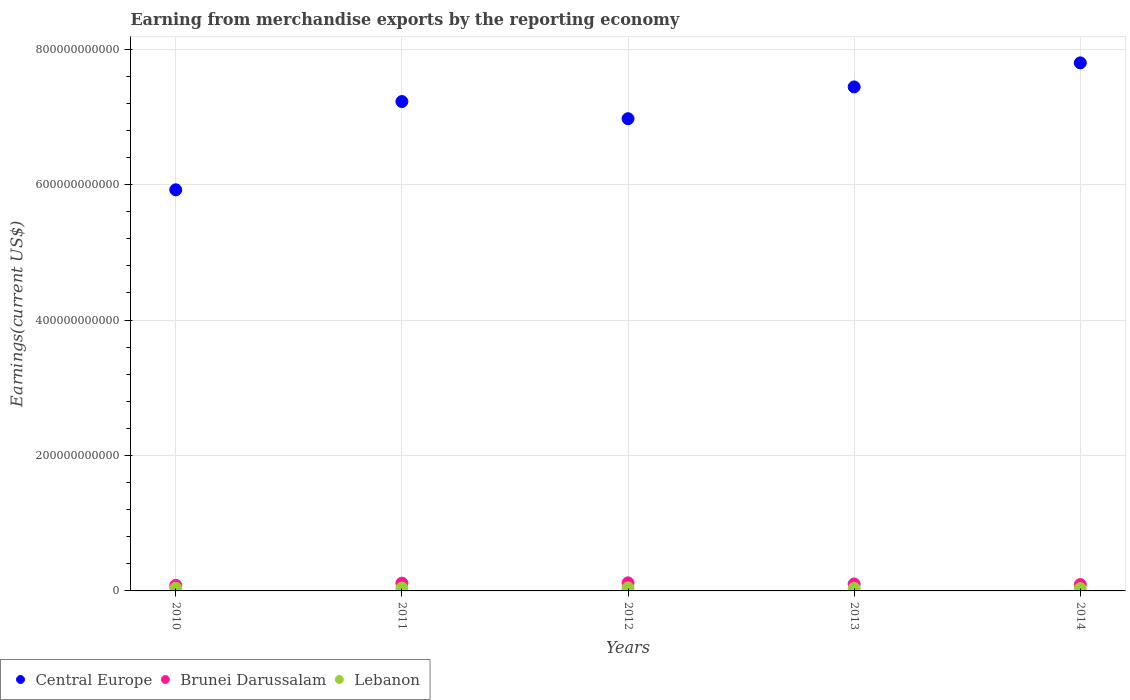What is the amount earned from merchandise exports in Brunei Darussalam in 2011?
Provide a succinct answer. 1.15e+1. Across all years, what is the maximum amount earned from merchandise exports in Central Europe?
Offer a terse response. 7.80e+11. Across all years, what is the minimum amount earned from merchandise exports in Central Europe?
Keep it short and to the point. 5.92e+11. What is the total amount earned from merchandise exports in Central Europe in the graph?
Offer a terse response. 3.54e+12. What is the difference between the amount earned from merchandise exports in Brunei Darussalam in 2013 and that in 2014?
Offer a very short reply. 9.11e+08. What is the difference between the amount earned from merchandise exports in Lebanon in 2011 and the amount earned from merchandise exports in Brunei Darussalam in 2014?
Your answer should be compact. -5.16e+09. What is the average amount earned from merchandise exports in Lebanon per year?
Your answer should be compact. 3.93e+09. In the year 2011, what is the difference between the amount earned from merchandise exports in Central Europe and amount earned from merchandise exports in Brunei Darussalam?
Keep it short and to the point. 7.11e+11. What is the ratio of the amount earned from merchandise exports in Lebanon in 2010 to that in 2012?
Your response must be concise. 0.86. Is the amount earned from merchandise exports in Lebanon in 2013 less than that in 2014?
Give a very brief answer. No. Is the difference between the amount earned from merchandise exports in Central Europe in 2010 and 2013 greater than the difference between the amount earned from merchandise exports in Brunei Darussalam in 2010 and 2013?
Offer a terse response. No. What is the difference between the highest and the second highest amount earned from merchandise exports in Lebanon?
Provide a succinct answer. 2.82e+08. What is the difference between the highest and the lowest amount earned from merchandise exports in Brunei Darussalam?
Your answer should be compact. 3.66e+09. How many dotlines are there?
Provide a short and direct response. 3. How many years are there in the graph?
Your answer should be compact. 5. What is the difference between two consecutive major ticks on the Y-axis?
Provide a short and direct response. 2.00e+11. Does the graph contain any zero values?
Your answer should be very brief. No. Where does the legend appear in the graph?
Make the answer very short. Bottom left. What is the title of the graph?
Ensure brevity in your answer.  Earning from merchandise exports by the reporting economy. What is the label or title of the X-axis?
Ensure brevity in your answer.  Years. What is the label or title of the Y-axis?
Your answer should be compact. Earnings(current US$). What is the Earnings(current US$) in Central Europe in 2010?
Provide a short and direct response. 5.92e+11. What is the Earnings(current US$) of Brunei Darussalam in 2010?
Provide a short and direct response. 8.26e+09. What is the Earnings(current US$) of Lebanon in 2010?
Your answer should be very brief. 3.86e+09. What is the Earnings(current US$) in Central Europe in 2011?
Your answer should be compact. 7.23e+11. What is the Earnings(current US$) of Brunei Darussalam in 2011?
Give a very brief answer. 1.15e+1. What is the Earnings(current US$) of Lebanon in 2011?
Your answer should be compact. 4.20e+09. What is the Earnings(current US$) of Central Europe in 2012?
Your answer should be very brief. 6.97e+11. What is the Earnings(current US$) of Brunei Darussalam in 2012?
Offer a terse response. 1.19e+1. What is the Earnings(current US$) of Lebanon in 2012?
Your answer should be compact. 4.48e+09. What is the Earnings(current US$) of Central Europe in 2013?
Your answer should be compact. 7.44e+11. What is the Earnings(current US$) in Brunei Darussalam in 2013?
Make the answer very short. 1.03e+1. What is the Earnings(current US$) of Lebanon in 2013?
Your response must be concise. 3.70e+09. What is the Earnings(current US$) in Central Europe in 2014?
Your answer should be compact. 7.80e+11. What is the Earnings(current US$) of Brunei Darussalam in 2014?
Offer a very short reply. 9.37e+09. What is the Earnings(current US$) of Lebanon in 2014?
Ensure brevity in your answer.  3.41e+09. Across all years, what is the maximum Earnings(current US$) in Central Europe?
Your answer should be compact. 7.80e+11. Across all years, what is the maximum Earnings(current US$) of Brunei Darussalam?
Your response must be concise. 1.19e+1. Across all years, what is the maximum Earnings(current US$) of Lebanon?
Provide a succinct answer. 4.48e+09. Across all years, what is the minimum Earnings(current US$) in Central Europe?
Your answer should be compact. 5.92e+11. Across all years, what is the minimum Earnings(current US$) of Brunei Darussalam?
Give a very brief answer. 8.26e+09. Across all years, what is the minimum Earnings(current US$) in Lebanon?
Your response must be concise. 3.41e+09. What is the total Earnings(current US$) of Central Europe in the graph?
Your response must be concise. 3.54e+12. What is the total Earnings(current US$) of Brunei Darussalam in the graph?
Provide a succinct answer. 5.13e+1. What is the total Earnings(current US$) of Lebanon in the graph?
Offer a very short reply. 1.96e+1. What is the difference between the Earnings(current US$) of Central Europe in 2010 and that in 2011?
Keep it short and to the point. -1.30e+11. What is the difference between the Earnings(current US$) of Brunei Darussalam in 2010 and that in 2011?
Ensure brevity in your answer.  -3.23e+09. What is the difference between the Earnings(current US$) in Lebanon in 2010 and that in 2011?
Ensure brevity in your answer.  -3.42e+08. What is the difference between the Earnings(current US$) in Central Europe in 2010 and that in 2012?
Your answer should be very brief. -1.05e+11. What is the difference between the Earnings(current US$) of Brunei Darussalam in 2010 and that in 2012?
Keep it short and to the point. -3.66e+09. What is the difference between the Earnings(current US$) of Lebanon in 2010 and that in 2012?
Ensure brevity in your answer.  -6.24e+08. What is the difference between the Earnings(current US$) of Central Europe in 2010 and that in 2013?
Offer a terse response. -1.52e+11. What is the difference between the Earnings(current US$) of Brunei Darussalam in 2010 and that in 2013?
Your response must be concise. -2.02e+09. What is the difference between the Earnings(current US$) of Lebanon in 2010 and that in 2013?
Give a very brief answer. 1.64e+08. What is the difference between the Earnings(current US$) in Central Europe in 2010 and that in 2014?
Your answer should be compact. -1.87e+11. What is the difference between the Earnings(current US$) of Brunei Darussalam in 2010 and that in 2014?
Offer a very short reply. -1.11e+09. What is the difference between the Earnings(current US$) in Lebanon in 2010 and that in 2014?
Provide a succinct answer. 4.49e+08. What is the difference between the Earnings(current US$) of Central Europe in 2011 and that in 2012?
Offer a terse response. 2.54e+1. What is the difference between the Earnings(current US$) in Brunei Darussalam in 2011 and that in 2012?
Keep it short and to the point. -4.32e+08. What is the difference between the Earnings(current US$) in Lebanon in 2011 and that in 2012?
Offer a terse response. -2.82e+08. What is the difference between the Earnings(current US$) of Central Europe in 2011 and that in 2013?
Make the answer very short. -2.16e+1. What is the difference between the Earnings(current US$) in Brunei Darussalam in 2011 and that in 2013?
Offer a very short reply. 1.21e+09. What is the difference between the Earnings(current US$) in Lebanon in 2011 and that in 2013?
Provide a short and direct response. 5.06e+08. What is the difference between the Earnings(current US$) in Central Europe in 2011 and that in 2014?
Give a very brief answer. -5.71e+1. What is the difference between the Earnings(current US$) of Brunei Darussalam in 2011 and that in 2014?
Your response must be concise. 2.12e+09. What is the difference between the Earnings(current US$) in Lebanon in 2011 and that in 2014?
Provide a short and direct response. 7.91e+08. What is the difference between the Earnings(current US$) of Central Europe in 2012 and that in 2013?
Offer a very short reply. -4.69e+1. What is the difference between the Earnings(current US$) in Brunei Darussalam in 2012 and that in 2013?
Ensure brevity in your answer.  1.64e+09. What is the difference between the Earnings(current US$) in Lebanon in 2012 and that in 2013?
Your response must be concise. 7.88e+08. What is the difference between the Earnings(current US$) in Central Europe in 2012 and that in 2014?
Give a very brief answer. -8.25e+1. What is the difference between the Earnings(current US$) of Brunei Darussalam in 2012 and that in 2014?
Your response must be concise. 2.55e+09. What is the difference between the Earnings(current US$) in Lebanon in 2012 and that in 2014?
Your answer should be very brief. 1.07e+09. What is the difference between the Earnings(current US$) of Central Europe in 2013 and that in 2014?
Ensure brevity in your answer.  -3.55e+1. What is the difference between the Earnings(current US$) of Brunei Darussalam in 2013 and that in 2014?
Give a very brief answer. 9.11e+08. What is the difference between the Earnings(current US$) in Lebanon in 2013 and that in 2014?
Your answer should be very brief. 2.85e+08. What is the difference between the Earnings(current US$) of Central Europe in 2010 and the Earnings(current US$) of Brunei Darussalam in 2011?
Ensure brevity in your answer.  5.81e+11. What is the difference between the Earnings(current US$) of Central Europe in 2010 and the Earnings(current US$) of Lebanon in 2011?
Provide a short and direct response. 5.88e+11. What is the difference between the Earnings(current US$) in Brunei Darussalam in 2010 and the Earnings(current US$) in Lebanon in 2011?
Your response must be concise. 4.05e+09. What is the difference between the Earnings(current US$) in Central Europe in 2010 and the Earnings(current US$) in Brunei Darussalam in 2012?
Offer a very short reply. 5.80e+11. What is the difference between the Earnings(current US$) in Central Europe in 2010 and the Earnings(current US$) in Lebanon in 2012?
Make the answer very short. 5.88e+11. What is the difference between the Earnings(current US$) of Brunei Darussalam in 2010 and the Earnings(current US$) of Lebanon in 2012?
Offer a very short reply. 3.77e+09. What is the difference between the Earnings(current US$) of Central Europe in 2010 and the Earnings(current US$) of Brunei Darussalam in 2013?
Your answer should be compact. 5.82e+11. What is the difference between the Earnings(current US$) of Central Europe in 2010 and the Earnings(current US$) of Lebanon in 2013?
Your answer should be very brief. 5.89e+11. What is the difference between the Earnings(current US$) in Brunei Darussalam in 2010 and the Earnings(current US$) in Lebanon in 2013?
Provide a short and direct response. 4.56e+09. What is the difference between the Earnings(current US$) of Central Europe in 2010 and the Earnings(current US$) of Brunei Darussalam in 2014?
Provide a short and direct response. 5.83e+11. What is the difference between the Earnings(current US$) in Central Europe in 2010 and the Earnings(current US$) in Lebanon in 2014?
Provide a short and direct response. 5.89e+11. What is the difference between the Earnings(current US$) in Brunei Darussalam in 2010 and the Earnings(current US$) in Lebanon in 2014?
Provide a succinct answer. 4.85e+09. What is the difference between the Earnings(current US$) of Central Europe in 2011 and the Earnings(current US$) of Brunei Darussalam in 2012?
Ensure brevity in your answer.  7.11e+11. What is the difference between the Earnings(current US$) in Central Europe in 2011 and the Earnings(current US$) in Lebanon in 2012?
Ensure brevity in your answer.  7.18e+11. What is the difference between the Earnings(current US$) in Brunei Darussalam in 2011 and the Earnings(current US$) in Lebanon in 2012?
Provide a succinct answer. 7.00e+09. What is the difference between the Earnings(current US$) in Central Europe in 2011 and the Earnings(current US$) in Brunei Darussalam in 2013?
Keep it short and to the point. 7.12e+11. What is the difference between the Earnings(current US$) of Central Europe in 2011 and the Earnings(current US$) of Lebanon in 2013?
Your answer should be very brief. 7.19e+11. What is the difference between the Earnings(current US$) in Brunei Darussalam in 2011 and the Earnings(current US$) in Lebanon in 2013?
Ensure brevity in your answer.  7.79e+09. What is the difference between the Earnings(current US$) of Central Europe in 2011 and the Earnings(current US$) of Brunei Darussalam in 2014?
Offer a terse response. 7.13e+11. What is the difference between the Earnings(current US$) in Central Europe in 2011 and the Earnings(current US$) in Lebanon in 2014?
Your answer should be compact. 7.19e+11. What is the difference between the Earnings(current US$) in Brunei Darussalam in 2011 and the Earnings(current US$) in Lebanon in 2014?
Provide a succinct answer. 8.07e+09. What is the difference between the Earnings(current US$) of Central Europe in 2012 and the Earnings(current US$) of Brunei Darussalam in 2013?
Make the answer very short. 6.87e+11. What is the difference between the Earnings(current US$) in Central Europe in 2012 and the Earnings(current US$) in Lebanon in 2013?
Offer a terse response. 6.94e+11. What is the difference between the Earnings(current US$) in Brunei Darussalam in 2012 and the Earnings(current US$) in Lebanon in 2013?
Give a very brief answer. 8.22e+09. What is the difference between the Earnings(current US$) of Central Europe in 2012 and the Earnings(current US$) of Brunei Darussalam in 2014?
Give a very brief answer. 6.88e+11. What is the difference between the Earnings(current US$) in Central Europe in 2012 and the Earnings(current US$) in Lebanon in 2014?
Your answer should be very brief. 6.94e+11. What is the difference between the Earnings(current US$) of Brunei Darussalam in 2012 and the Earnings(current US$) of Lebanon in 2014?
Keep it short and to the point. 8.51e+09. What is the difference between the Earnings(current US$) of Central Europe in 2013 and the Earnings(current US$) of Brunei Darussalam in 2014?
Provide a short and direct response. 7.35e+11. What is the difference between the Earnings(current US$) of Central Europe in 2013 and the Earnings(current US$) of Lebanon in 2014?
Provide a short and direct response. 7.41e+11. What is the difference between the Earnings(current US$) of Brunei Darussalam in 2013 and the Earnings(current US$) of Lebanon in 2014?
Provide a succinct answer. 6.87e+09. What is the average Earnings(current US$) in Central Europe per year?
Your response must be concise. 7.07e+11. What is the average Earnings(current US$) of Brunei Darussalam per year?
Keep it short and to the point. 1.03e+1. What is the average Earnings(current US$) in Lebanon per year?
Provide a succinct answer. 3.93e+09. In the year 2010, what is the difference between the Earnings(current US$) in Central Europe and Earnings(current US$) in Brunei Darussalam?
Keep it short and to the point. 5.84e+11. In the year 2010, what is the difference between the Earnings(current US$) of Central Europe and Earnings(current US$) of Lebanon?
Your response must be concise. 5.89e+11. In the year 2010, what is the difference between the Earnings(current US$) of Brunei Darussalam and Earnings(current US$) of Lebanon?
Your answer should be compact. 4.40e+09. In the year 2011, what is the difference between the Earnings(current US$) in Central Europe and Earnings(current US$) in Brunei Darussalam?
Keep it short and to the point. 7.11e+11. In the year 2011, what is the difference between the Earnings(current US$) in Central Europe and Earnings(current US$) in Lebanon?
Provide a short and direct response. 7.19e+11. In the year 2011, what is the difference between the Earnings(current US$) in Brunei Darussalam and Earnings(current US$) in Lebanon?
Your answer should be very brief. 7.28e+09. In the year 2012, what is the difference between the Earnings(current US$) in Central Europe and Earnings(current US$) in Brunei Darussalam?
Offer a terse response. 6.85e+11. In the year 2012, what is the difference between the Earnings(current US$) of Central Europe and Earnings(current US$) of Lebanon?
Give a very brief answer. 6.93e+11. In the year 2012, what is the difference between the Earnings(current US$) of Brunei Darussalam and Earnings(current US$) of Lebanon?
Offer a very short reply. 7.43e+09. In the year 2013, what is the difference between the Earnings(current US$) in Central Europe and Earnings(current US$) in Brunei Darussalam?
Your response must be concise. 7.34e+11. In the year 2013, what is the difference between the Earnings(current US$) in Central Europe and Earnings(current US$) in Lebanon?
Provide a short and direct response. 7.41e+11. In the year 2013, what is the difference between the Earnings(current US$) of Brunei Darussalam and Earnings(current US$) of Lebanon?
Give a very brief answer. 6.58e+09. In the year 2014, what is the difference between the Earnings(current US$) of Central Europe and Earnings(current US$) of Brunei Darussalam?
Your answer should be compact. 7.71e+11. In the year 2014, what is the difference between the Earnings(current US$) of Central Europe and Earnings(current US$) of Lebanon?
Provide a succinct answer. 7.76e+11. In the year 2014, what is the difference between the Earnings(current US$) of Brunei Darussalam and Earnings(current US$) of Lebanon?
Ensure brevity in your answer.  5.95e+09. What is the ratio of the Earnings(current US$) of Central Europe in 2010 to that in 2011?
Offer a very short reply. 0.82. What is the ratio of the Earnings(current US$) in Brunei Darussalam in 2010 to that in 2011?
Provide a succinct answer. 0.72. What is the ratio of the Earnings(current US$) in Lebanon in 2010 to that in 2011?
Provide a succinct answer. 0.92. What is the ratio of the Earnings(current US$) of Central Europe in 2010 to that in 2012?
Keep it short and to the point. 0.85. What is the ratio of the Earnings(current US$) in Brunei Darussalam in 2010 to that in 2012?
Your answer should be compact. 0.69. What is the ratio of the Earnings(current US$) in Lebanon in 2010 to that in 2012?
Ensure brevity in your answer.  0.86. What is the ratio of the Earnings(current US$) of Central Europe in 2010 to that in 2013?
Give a very brief answer. 0.8. What is the ratio of the Earnings(current US$) in Brunei Darussalam in 2010 to that in 2013?
Ensure brevity in your answer.  0.8. What is the ratio of the Earnings(current US$) of Lebanon in 2010 to that in 2013?
Provide a short and direct response. 1.04. What is the ratio of the Earnings(current US$) in Central Europe in 2010 to that in 2014?
Your answer should be compact. 0.76. What is the ratio of the Earnings(current US$) of Brunei Darussalam in 2010 to that in 2014?
Keep it short and to the point. 0.88. What is the ratio of the Earnings(current US$) of Lebanon in 2010 to that in 2014?
Your answer should be very brief. 1.13. What is the ratio of the Earnings(current US$) in Central Europe in 2011 to that in 2012?
Give a very brief answer. 1.04. What is the ratio of the Earnings(current US$) in Brunei Darussalam in 2011 to that in 2012?
Ensure brevity in your answer.  0.96. What is the ratio of the Earnings(current US$) of Lebanon in 2011 to that in 2012?
Provide a succinct answer. 0.94. What is the ratio of the Earnings(current US$) of Central Europe in 2011 to that in 2013?
Ensure brevity in your answer.  0.97. What is the ratio of the Earnings(current US$) in Brunei Darussalam in 2011 to that in 2013?
Keep it short and to the point. 1.12. What is the ratio of the Earnings(current US$) in Lebanon in 2011 to that in 2013?
Give a very brief answer. 1.14. What is the ratio of the Earnings(current US$) in Central Europe in 2011 to that in 2014?
Your answer should be very brief. 0.93. What is the ratio of the Earnings(current US$) in Brunei Darussalam in 2011 to that in 2014?
Give a very brief answer. 1.23. What is the ratio of the Earnings(current US$) of Lebanon in 2011 to that in 2014?
Provide a short and direct response. 1.23. What is the ratio of the Earnings(current US$) of Central Europe in 2012 to that in 2013?
Provide a succinct answer. 0.94. What is the ratio of the Earnings(current US$) of Brunei Darussalam in 2012 to that in 2013?
Your answer should be very brief. 1.16. What is the ratio of the Earnings(current US$) of Lebanon in 2012 to that in 2013?
Your answer should be very brief. 1.21. What is the ratio of the Earnings(current US$) of Central Europe in 2012 to that in 2014?
Provide a succinct answer. 0.89. What is the ratio of the Earnings(current US$) of Brunei Darussalam in 2012 to that in 2014?
Your response must be concise. 1.27. What is the ratio of the Earnings(current US$) of Lebanon in 2012 to that in 2014?
Offer a very short reply. 1.31. What is the ratio of the Earnings(current US$) in Central Europe in 2013 to that in 2014?
Make the answer very short. 0.95. What is the ratio of the Earnings(current US$) in Brunei Darussalam in 2013 to that in 2014?
Keep it short and to the point. 1.1. What is the ratio of the Earnings(current US$) in Lebanon in 2013 to that in 2014?
Provide a short and direct response. 1.08. What is the difference between the highest and the second highest Earnings(current US$) of Central Europe?
Offer a terse response. 3.55e+1. What is the difference between the highest and the second highest Earnings(current US$) of Brunei Darussalam?
Offer a terse response. 4.32e+08. What is the difference between the highest and the second highest Earnings(current US$) in Lebanon?
Offer a very short reply. 2.82e+08. What is the difference between the highest and the lowest Earnings(current US$) of Central Europe?
Your answer should be compact. 1.87e+11. What is the difference between the highest and the lowest Earnings(current US$) in Brunei Darussalam?
Offer a very short reply. 3.66e+09. What is the difference between the highest and the lowest Earnings(current US$) in Lebanon?
Offer a terse response. 1.07e+09. 